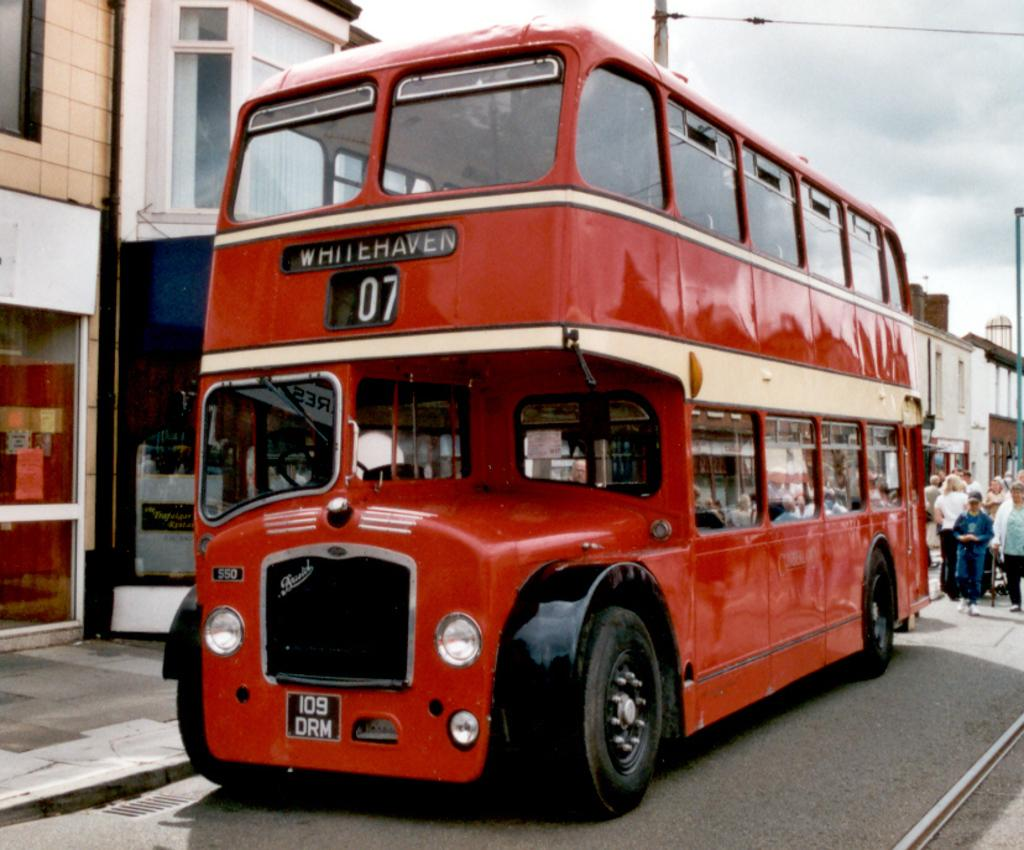What type of vehicle is in the image? There is a red double-decker bus in the image. Where is the bus located? The bus is on the road. Are there any other people or objects visible in the image? Yes, there are people on the road and houses visible in the image. How would you describe the weather based on the image? The sky is cloudy in the background, suggesting a potentially overcast or cloudy day. How many times does the bus sneeze in the image? Buses do not sneeze, as they are inanimate objects. The question is not applicable to the image. 